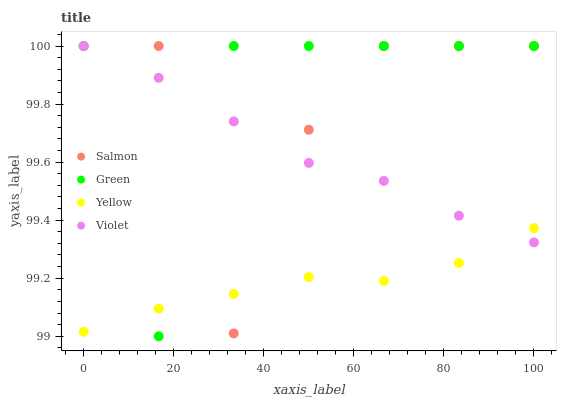Does Yellow have the minimum area under the curve?
Answer yes or no. Yes. Does Green have the maximum area under the curve?
Answer yes or no. Yes. Does Salmon have the minimum area under the curve?
Answer yes or no. No. Does Salmon have the maximum area under the curve?
Answer yes or no. No. Is Violet the smoothest?
Answer yes or no. Yes. Is Salmon the roughest?
Answer yes or no. Yes. Is Yellow the smoothest?
Answer yes or no. No. Is Yellow the roughest?
Answer yes or no. No. Does Green have the lowest value?
Answer yes or no. Yes. Does Salmon have the lowest value?
Answer yes or no. No. Does Violet have the highest value?
Answer yes or no. Yes. Does Yellow have the highest value?
Answer yes or no. No. Does Yellow intersect Violet?
Answer yes or no. Yes. Is Yellow less than Violet?
Answer yes or no. No. Is Yellow greater than Violet?
Answer yes or no. No. 